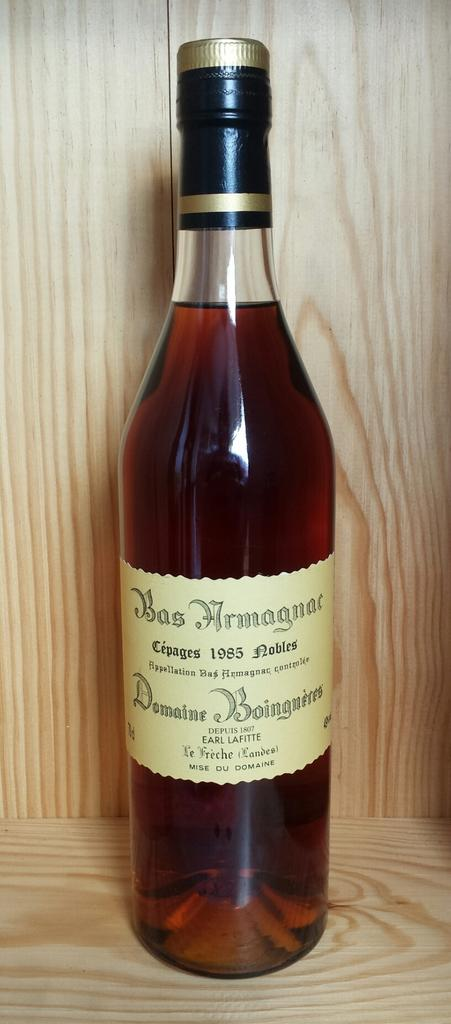Provide a one-sentence caption for the provided image. a wine bottle with a label that says BasArmagnae. 